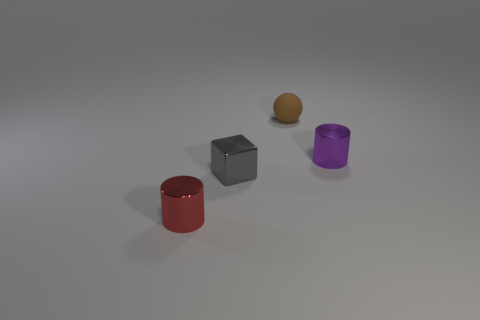Are there any patterns or shadows present in the image? Yes, each object casts a soft shadow on the ground due to the lighting above. There are no distinctive patterns visible on the surface they rest upon or on the objects themselves. 